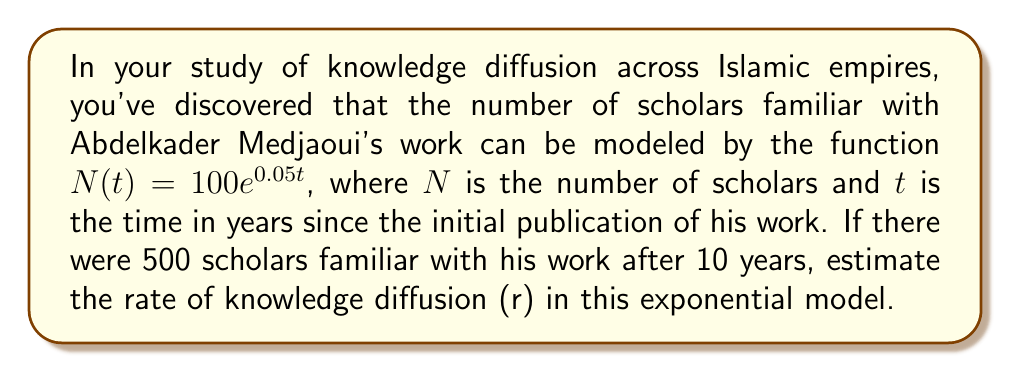Could you help me with this problem? To solve this problem, we'll use the exponential growth model and the given information to find the rate of knowledge diffusion. Let's approach this step-by-step:

1) The general form of an exponential growth model is:

   $N(t) = N_0e^{rt}$

   Where $N_0$ is the initial value, $r$ is the rate of growth, and $t$ is time.

2) We're given that $N(t) = 100e^{0.05t}$, so we know:
   
   $N_0 = 100$
   $r = 0.05$

3) We're also told that after 10 years, there were 500 scholars. Let's use this information:

   $500 = 100e^{r(10)}$

4) Now, let's solve for $r$:

   $\frac{500}{100} = e^{10r}$
   $5 = e^{10r}$

5) Taking the natural log of both sides:

   $\ln(5) = 10r$

6) Solving for $r$:

   $r = \frac{\ln(5)}{10} \approx 0.16$

7) This means the actual rate of knowledge diffusion is approximately 0.16, or 16% per year, which is higher than the initial estimate of 0.05 or 5% per year.
Answer: The estimated rate of knowledge diffusion (r) is approximately 0.16 or 16% per year. 